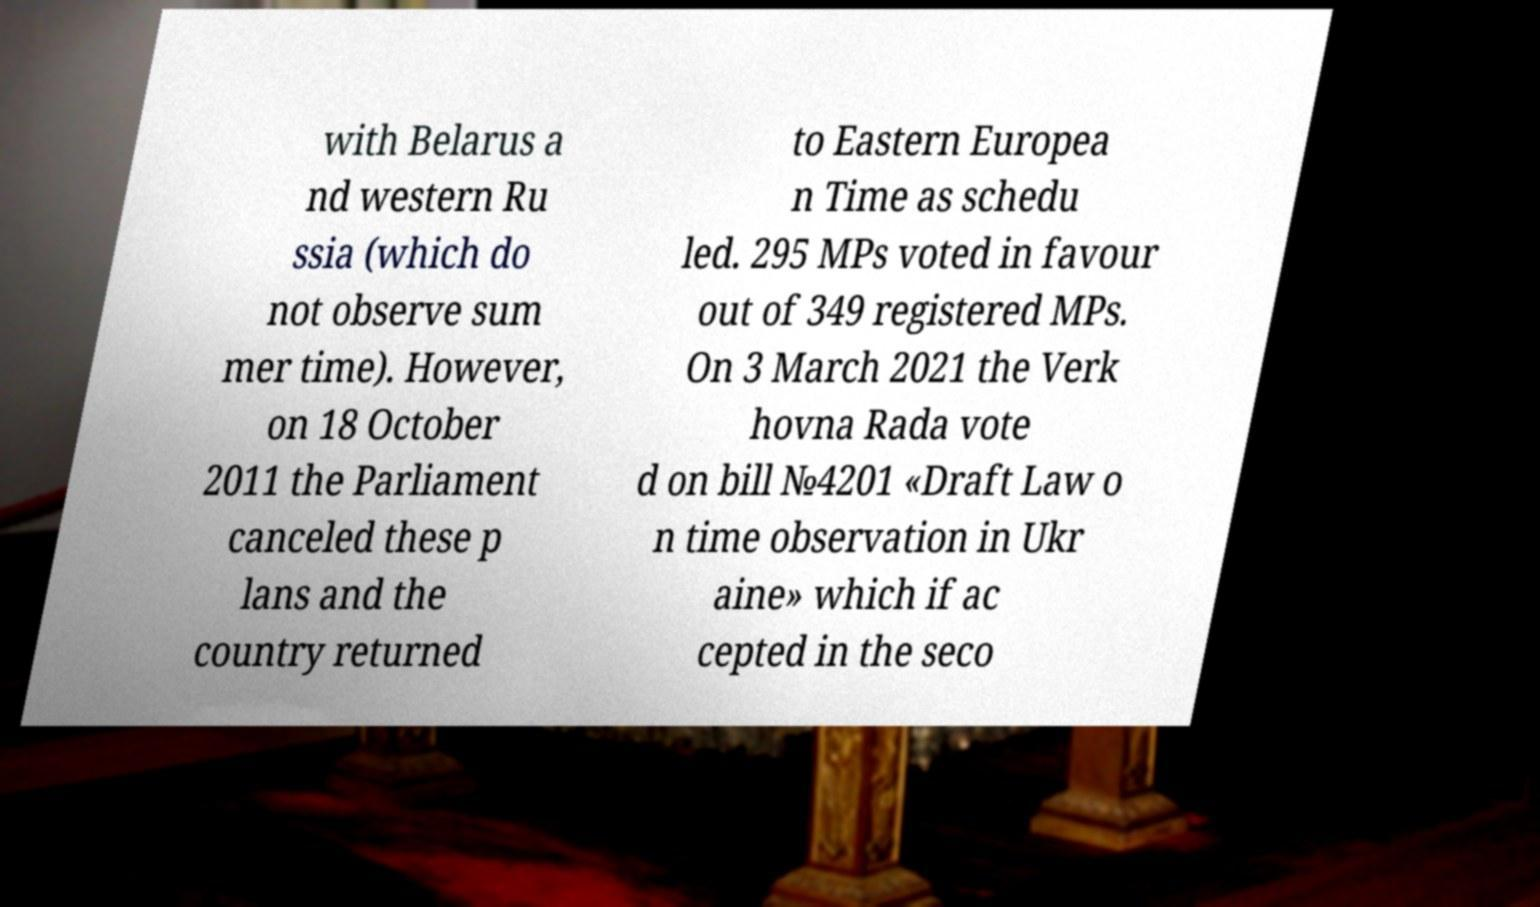For documentation purposes, I need the text within this image transcribed. Could you provide that? with Belarus a nd western Ru ssia (which do not observe sum mer time). However, on 18 October 2011 the Parliament canceled these p lans and the country returned to Eastern Europea n Time as schedu led. 295 MPs voted in favour out of 349 registered MPs. On 3 March 2021 the Verk hovna Rada vote d on bill №4201 «Draft Law o n time observation in Ukr aine» which if ac cepted in the seco 